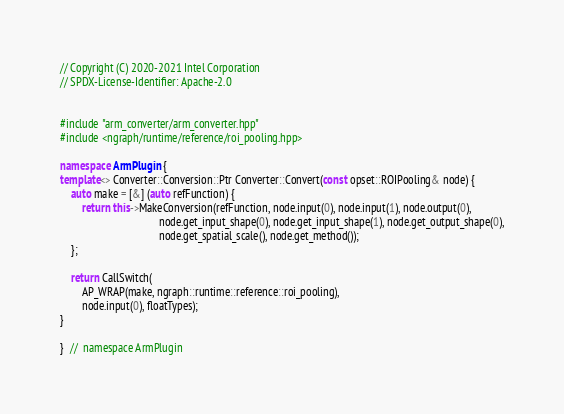Convert code to text. <code><loc_0><loc_0><loc_500><loc_500><_C++_>// Copyright (C) 2020-2021 Intel Corporation
// SPDX-License-Identifier: Apache-2.0


#include "arm_converter/arm_converter.hpp"
#include <ngraph/runtime/reference/roi_pooling.hpp>

namespace ArmPlugin {
template<> Converter::Conversion::Ptr Converter::Convert(const opset::ROIPooling& node) {
    auto make = [&] (auto refFunction) {
        return this->MakeConversion(refFunction, node.input(0), node.input(1), node.output(0),
                                    node.get_input_shape(0), node.get_input_shape(1), node.get_output_shape(0),
                                    node.get_spatial_scale(), node.get_method());
    };

    return CallSwitch(
        AP_WRAP(make, ngraph::runtime::reference::roi_pooling),
        node.input(0), floatTypes);
}

}  //  namespace ArmPlugin
</code> 